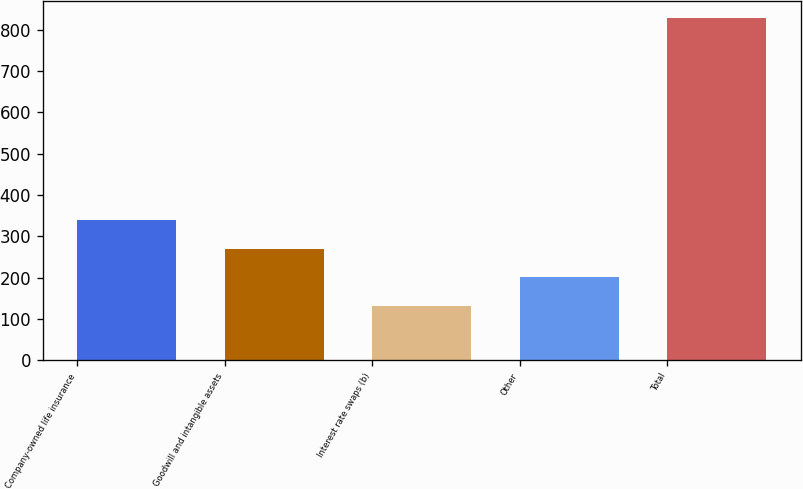Convert chart to OTSL. <chart><loc_0><loc_0><loc_500><loc_500><bar_chart><fcel>Company-owned life insurance<fcel>Goodwill and intangible assets<fcel>Interest rate swaps (b)<fcel>Other<fcel>Total<nl><fcel>340.4<fcel>270.6<fcel>131<fcel>200.8<fcel>829<nl></chart> 